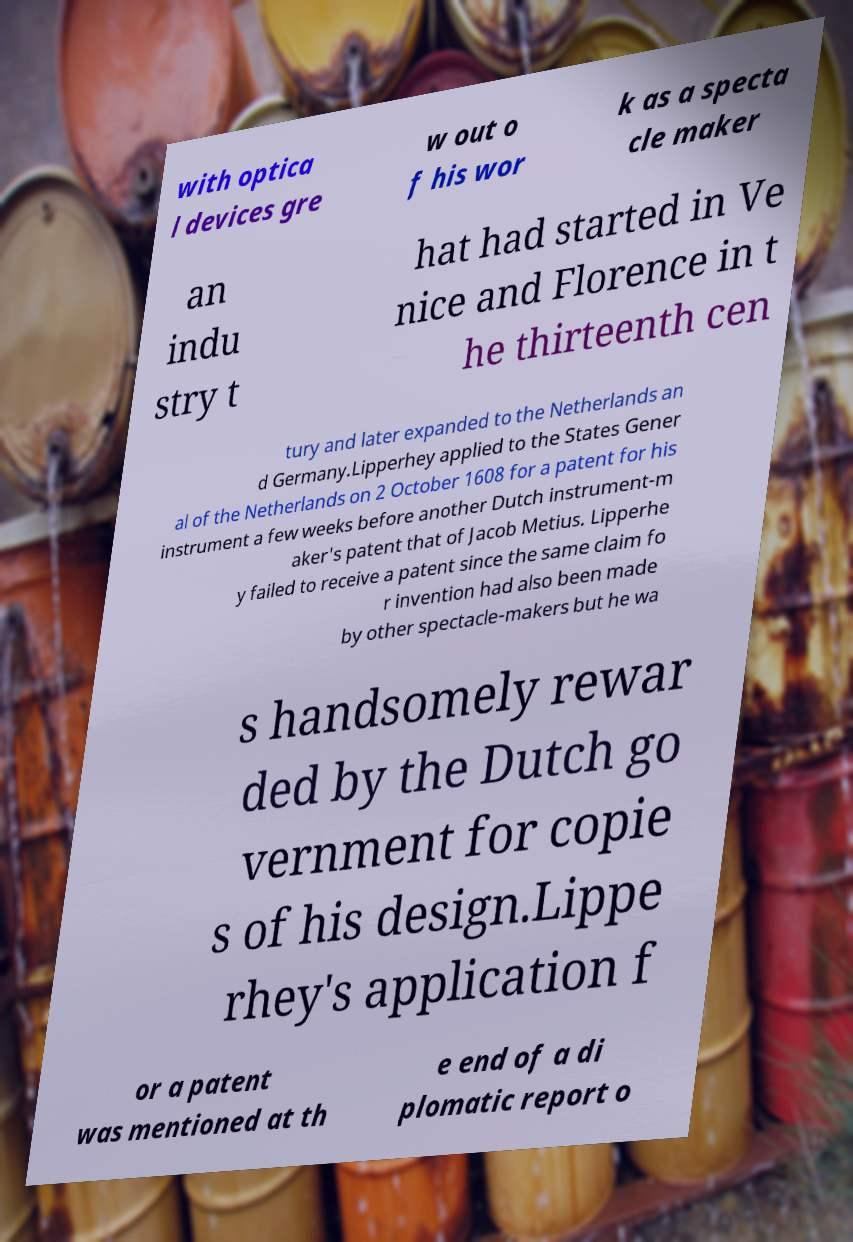There's text embedded in this image that I need extracted. Can you transcribe it verbatim? with optica l devices gre w out o f his wor k as a specta cle maker an indu stry t hat had started in Ve nice and Florence in t he thirteenth cen tury and later expanded to the Netherlands an d Germany.Lipperhey applied to the States Gener al of the Netherlands on 2 October 1608 for a patent for his instrument a few weeks before another Dutch instrument-m aker's patent that of Jacob Metius. Lipperhe y failed to receive a patent since the same claim fo r invention had also been made by other spectacle-makers but he wa s handsomely rewar ded by the Dutch go vernment for copie s of his design.Lippe rhey's application f or a patent was mentioned at th e end of a di plomatic report o 